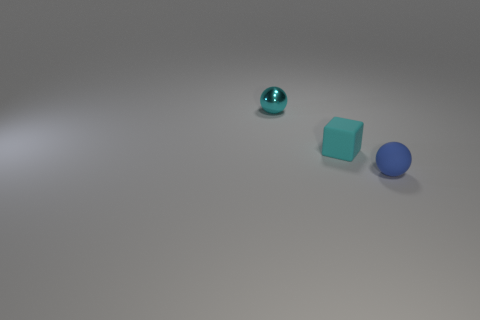Add 3 small blue matte spheres. How many objects exist? 6 Subtract all balls. How many objects are left? 1 Subtract all cyan shiny spheres. Subtract all small purple matte blocks. How many objects are left? 2 Add 2 small matte things. How many small matte things are left? 4 Add 1 large blue rubber objects. How many large blue rubber objects exist? 1 Subtract 0 gray cylinders. How many objects are left? 3 